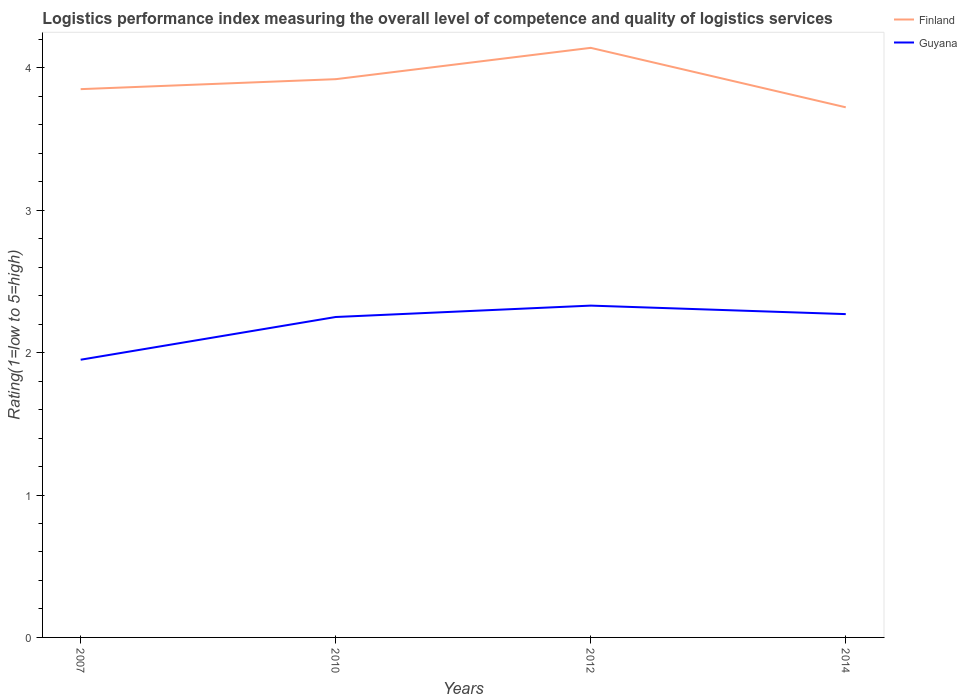How many different coloured lines are there?
Keep it short and to the point. 2. Across all years, what is the maximum Logistic performance index in Guyana?
Your response must be concise. 1.95. In which year was the Logistic performance index in Guyana maximum?
Offer a terse response. 2007. What is the total Logistic performance index in Finland in the graph?
Offer a terse response. 0.13. What is the difference between the highest and the second highest Logistic performance index in Guyana?
Provide a short and direct response. 0.38. How many years are there in the graph?
Offer a terse response. 4. Does the graph contain any zero values?
Your answer should be very brief. No. Where does the legend appear in the graph?
Provide a succinct answer. Top right. What is the title of the graph?
Offer a terse response. Logistics performance index measuring the overall level of competence and quality of logistics services. Does "Korea (Republic)" appear as one of the legend labels in the graph?
Offer a very short reply. No. What is the label or title of the X-axis?
Offer a very short reply. Years. What is the label or title of the Y-axis?
Make the answer very short. Rating(1=low to 5=high). What is the Rating(1=low to 5=high) of Finland in 2007?
Keep it short and to the point. 3.85. What is the Rating(1=low to 5=high) in Guyana in 2007?
Your answer should be very brief. 1.95. What is the Rating(1=low to 5=high) of Finland in 2010?
Offer a terse response. 3.92. What is the Rating(1=low to 5=high) of Guyana in 2010?
Give a very brief answer. 2.25. What is the Rating(1=low to 5=high) in Finland in 2012?
Your response must be concise. 4.14. What is the Rating(1=low to 5=high) of Guyana in 2012?
Offer a terse response. 2.33. What is the Rating(1=low to 5=high) in Finland in 2014?
Provide a short and direct response. 3.72. What is the Rating(1=low to 5=high) in Guyana in 2014?
Your response must be concise. 2.27. Across all years, what is the maximum Rating(1=low to 5=high) of Finland?
Your answer should be very brief. 4.14. Across all years, what is the maximum Rating(1=low to 5=high) in Guyana?
Provide a short and direct response. 2.33. Across all years, what is the minimum Rating(1=low to 5=high) in Finland?
Provide a succinct answer. 3.72. Across all years, what is the minimum Rating(1=low to 5=high) in Guyana?
Offer a very short reply. 1.95. What is the total Rating(1=low to 5=high) of Finland in the graph?
Offer a very short reply. 15.63. What is the total Rating(1=low to 5=high) of Guyana in the graph?
Ensure brevity in your answer.  8.8. What is the difference between the Rating(1=low to 5=high) in Finland in 2007 and that in 2010?
Provide a succinct answer. -0.07. What is the difference between the Rating(1=low to 5=high) in Guyana in 2007 and that in 2010?
Give a very brief answer. -0.3. What is the difference between the Rating(1=low to 5=high) of Finland in 2007 and that in 2012?
Give a very brief answer. -0.29. What is the difference between the Rating(1=low to 5=high) in Guyana in 2007 and that in 2012?
Your answer should be very brief. -0.38. What is the difference between the Rating(1=low to 5=high) of Finland in 2007 and that in 2014?
Provide a succinct answer. 0.13. What is the difference between the Rating(1=low to 5=high) of Guyana in 2007 and that in 2014?
Keep it short and to the point. -0.32. What is the difference between the Rating(1=low to 5=high) of Finland in 2010 and that in 2012?
Keep it short and to the point. -0.22. What is the difference between the Rating(1=low to 5=high) in Guyana in 2010 and that in 2012?
Your answer should be compact. -0.08. What is the difference between the Rating(1=low to 5=high) in Finland in 2010 and that in 2014?
Make the answer very short. 0.2. What is the difference between the Rating(1=low to 5=high) in Guyana in 2010 and that in 2014?
Offer a terse response. -0.02. What is the difference between the Rating(1=low to 5=high) of Finland in 2012 and that in 2014?
Make the answer very short. 0.42. What is the difference between the Rating(1=low to 5=high) of Guyana in 2012 and that in 2014?
Keep it short and to the point. 0.06. What is the difference between the Rating(1=low to 5=high) of Finland in 2007 and the Rating(1=low to 5=high) of Guyana in 2010?
Offer a very short reply. 1.6. What is the difference between the Rating(1=low to 5=high) of Finland in 2007 and the Rating(1=low to 5=high) of Guyana in 2012?
Ensure brevity in your answer.  1.52. What is the difference between the Rating(1=low to 5=high) of Finland in 2007 and the Rating(1=low to 5=high) of Guyana in 2014?
Keep it short and to the point. 1.58. What is the difference between the Rating(1=low to 5=high) of Finland in 2010 and the Rating(1=low to 5=high) of Guyana in 2012?
Your answer should be very brief. 1.59. What is the difference between the Rating(1=low to 5=high) in Finland in 2010 and the Rating(1=low to 5=high) in Guyana in 2014?
Offer a terse response. 1.65. What is the difference between the Rating(1=low to 5=high) in Finland in 2012 and the Rating(1=low to 5=high) in Guyana in 2014?
Your response must be concise. 1.87. What is the average Rating(1=low to 5=high) of Finland per year?
Provide a short and direct response. 3.91. What is the average Rating(1=low to 5=high) of Guyana per year?
Provide a succinct answer. 2.2. In the year 2010, what is the difference between the Rating(1=low to 5=high) in Finland and Rating(1=low to 5=high) in Guyana?
Give a very brief answer. 1.67. In the year 2012, what is the difference between the Rating(1=low to 5=high) in Finland and Rating(1=low to 5=high) in Guyana?
Your answer should be compact. 1.81. In the year 2014, what is the difference between the Rating(1=low to 5=high) in Finland and Rating(1=low to 5=high) in Guyana?
Your response must be concise. 1.45. What is the ratio of the Rating(1=low to 5=high) in Finland in 2007 to that in 2010?
Offer a very short reply. 0.98. What is the ratio of the Rating(1=low to 5=high) in Guyana in 2007 to that in 2010?
Your answer should be very brief. 0.87. What is the ratio of the Rating(1=low to 5=high) in Guyana in 2007 to that in 2012?
Keep it short and to the point. 0.84. What is the ratio of the Rating(1=low to 5=high) in Finland in 2007 to that in 2014?
Your answer should be very brief. 1.03. What is the ratio of the Rating(1=low to 5=high) of Guyana in 2007 to that in 2014?
Provide a succinct answer. 0.86. What is the ratio of the Rating(1=low to 5=high) in Finland in 2010 to that in 2012?
Give a very brief answer. 0.95. What is the ratio of the Rating(1=low to 5=high) of Guyana in 2010 to that in 2012?
Offer a terse response. 0.97. What is the ratio of the Rating(1=low to 5=high) in Finland in 2010 to that in 2014?
Your answer should be compact. 1.05. What is the ratio of the Rating(1=low to 5=high) in Finland in 2012 to that in 2014?
Your answer should be very brief. 1.11. What is the ratio of the Rating(1=low to 5=high) in Guyana in 2012 to that in 2014?
Your response must be concise. 1.03. What is the difference between the highest and the second highest Rating(1=low to 5=high) of Finland?
Ensure brevity in your answer.  0.22. What is the difference between the highest and the second highest Rating(1=low to 5=high) in Guyana?
Give a very brief answer. 0.06. What is the difference between the highest and the lowest Rating(1=low to 5=high) in Finland?
Keep it short and to the point. 0.42. What is the difference between the highest and the lowest Rating(1=low to 5=high) in Guyana?
Ensure brevity in your answer.  0.38. 